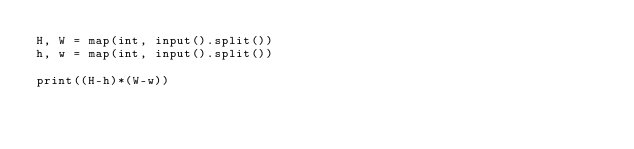<code> <loc_0><loc_0><loc_500><loc_500><_Python_>H, W = map(int, input().split())
h, w = map(int, input().split())

print((H-h)*(W-w))</code> 